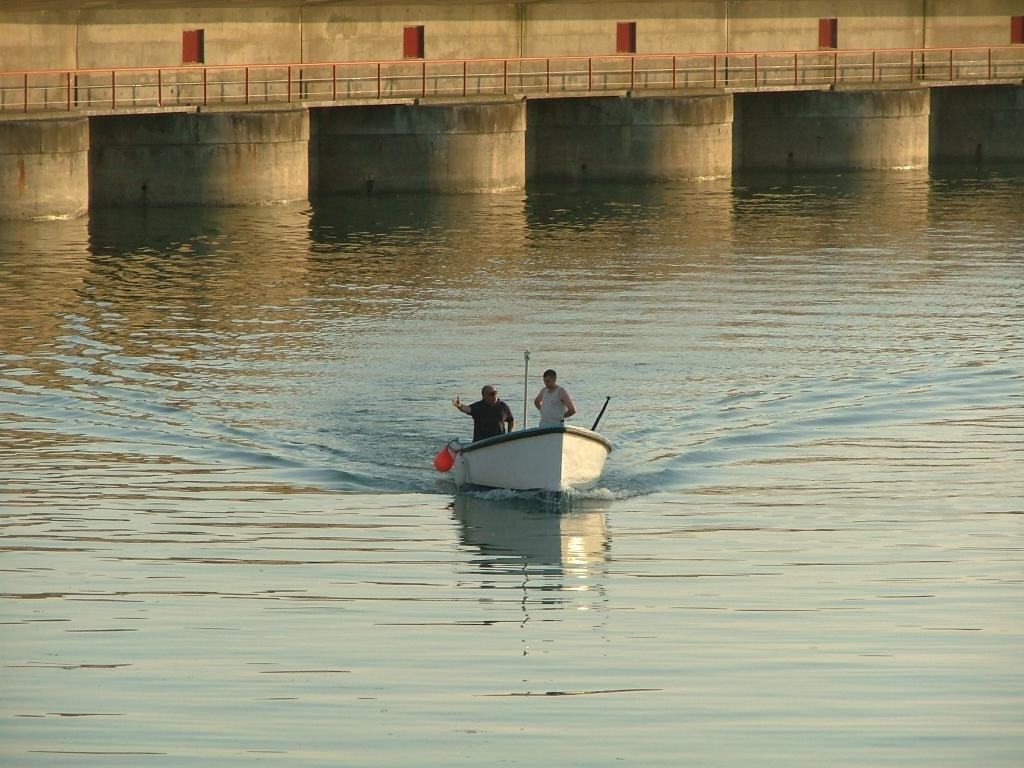What are the two people in the image doing? The two people are in a boat in the center of the image. What is at the bottom of the image? There is water at the bottom of the image. What can be seen in the background of the image? There is a bridge in the background of the image. What degree does the bee have in the image? There is no bee present in the image, so it cannot have a degree. What type of spade is being used by the people in the boat? There is no spade visible in the image; the people are in a boat on water. 